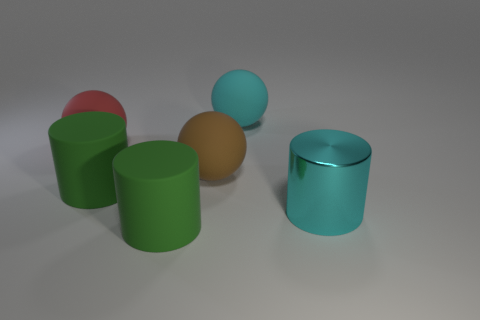The object that is the same color as the big metallic cylinder is what shape?
Provide a short and direct response. Sphere. Is the number of large brown matte objects behind the big red thing less than the number of metallic cylinders?
Offer a terse response. Yes. There is a large cyan matte thing; what shape is it?
Offer a very short reply. Sphere. How big is the rubber thing behind the large red object?
Offer a terse response. Large. There is a shiny object that is the same size as the cyan matte ball; what is its color?
Offer a very short reply. Cyan. Is there another large thing of the same color as the metal object?
Offer a very short reply. Yes. Is the number of cyan rubber balls that are right of the large cyan matte sphere less than the number of large red rubber objects behind the large brown matte object?
Your response must be concise. Yes. There is a big thing that is right of the brown matte object and on the left side of the cyan metallic cylinder; what material is it made of?
Provide a succinct answer. Rubber. Does the brown matte thing have the same shape as the large matte thing that is to the right of the big brown matte sphere?
Your answer should be compact. Yes. What number of other things are the same size as the brown matte sphere?
Your answer should be very brief. 5. 